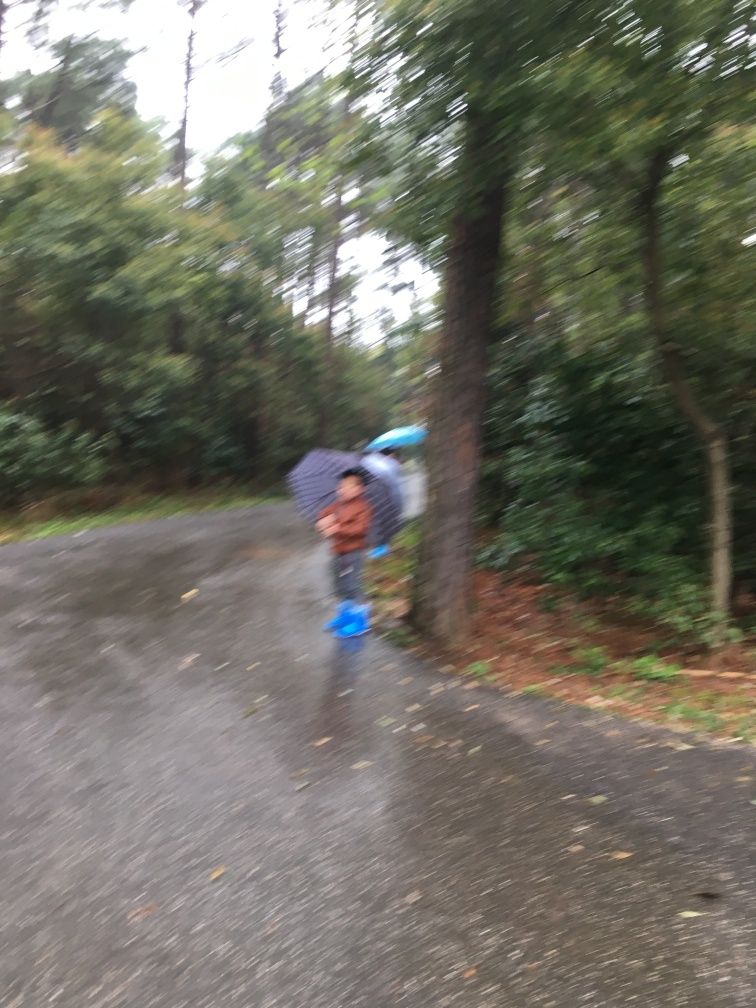What can you infer about the location in this image? The location seems to be a residential area with considerable greenery, such as trees and shrubs, which suggests it could be a suburban neighborhood. Anything else you can observe about the surroundings? The absence of people and vehicles, along with the natural setting, implies it's a quiet, possibly secluded area. The presence of fallen leaves on the ground suggests it might be autumn. 